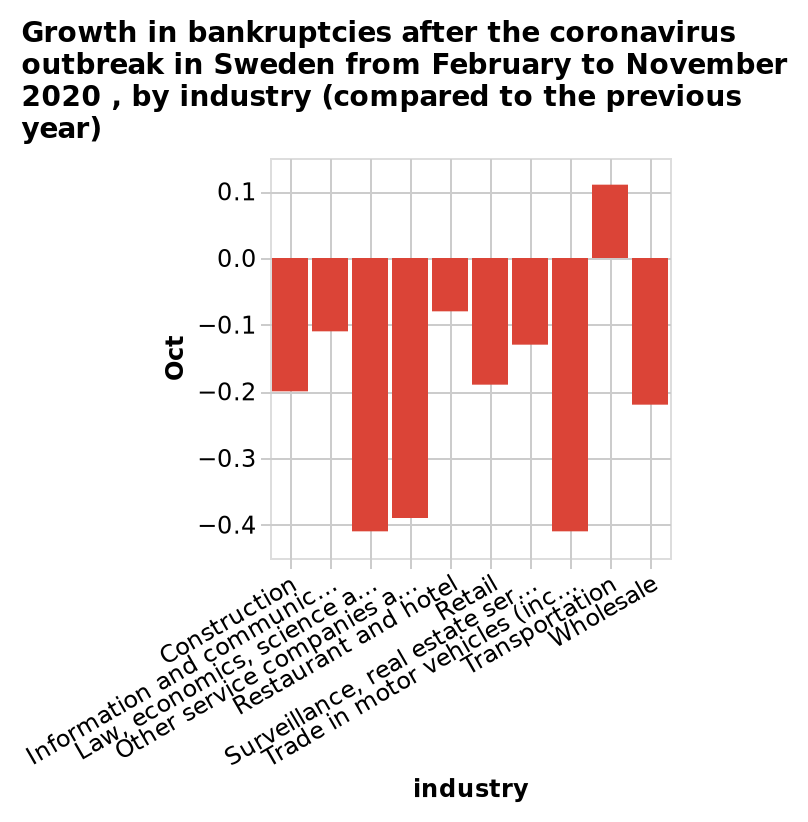<image>
Which sectors in Sweden showed a decrease in bankruptcies after the coronavirus outbreak in 2020? All other sectors in Sweden showed a decrease in bankruptcies after the coronavirus outbreak in 2020. How are the bankruptcies in each industry compared in the bar plot? The bankruptcies in each industry are compared to the previous year in the bar plot. What sector in Sweden experienced a growth in bankruptcies after the coronavirus outbreak in 2020? The transportation sector in Sweden experienced a growth in bankruptcies after the coronavirus outbreak in 2020. 